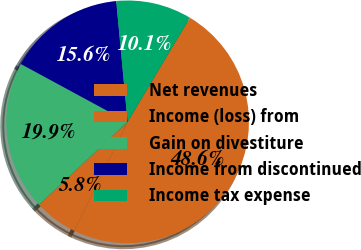<chart> <loc_0><loc_0><loc_500><loc_500><pie_chart><fcel>Net revenues<fcel>Income (loss) from<fcel>Gain on divestiture<fcel>Income from discontinued<fcel>Income tax expense<nl><fcel>48.63%<fcel>5.8%<fcel>19.88%<fcel>15.6%<fcel>10.08%<nl></chart> 